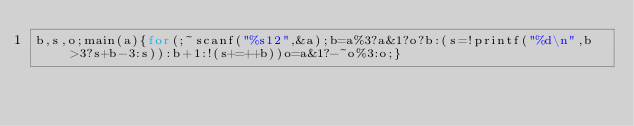<code> <loc_0><loc_0><loc_500><loc_500><_C_>b,s,o;main(a){for(;~scanf("%s12",&a);b=a%3?a&1?o?b:(s=!printf("%d\n",b>3?s+b-3:s)):b+1:!(s+=++b))o=a&1?-~o%3:o;}</code> 